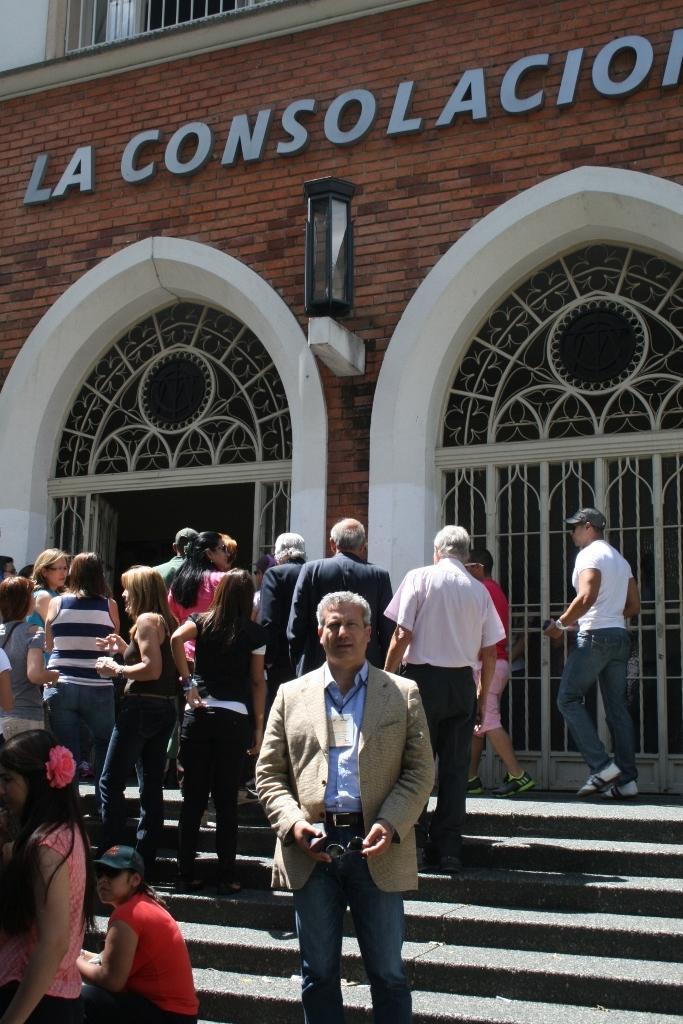Please provide a concise description of this image. In this image we can see a building. On the building we can see some text, in front of the building we can see a few people, among them some are holding the objects and also we can see a staircase and the doors. 